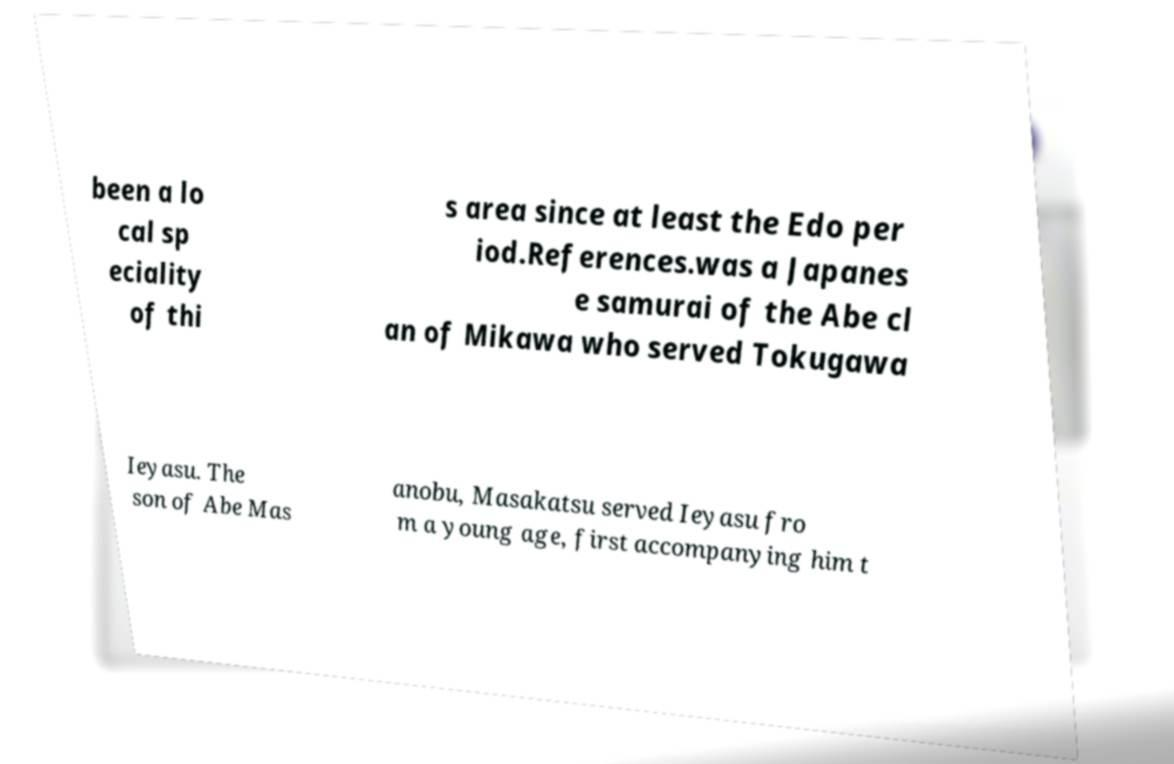What messages or text are displayed in this image? I need them in a readable, typed format. been a lo cal sp eciality of thi s area since at least the Edo per iod.References.was a Japanes e samurai of the Abe cl an of Mikawa who served Tokugawa Ieyasu. The son of Abe Mas anobu, Masakatsu served Ieyasu fro m a young age, first accompanying him t 